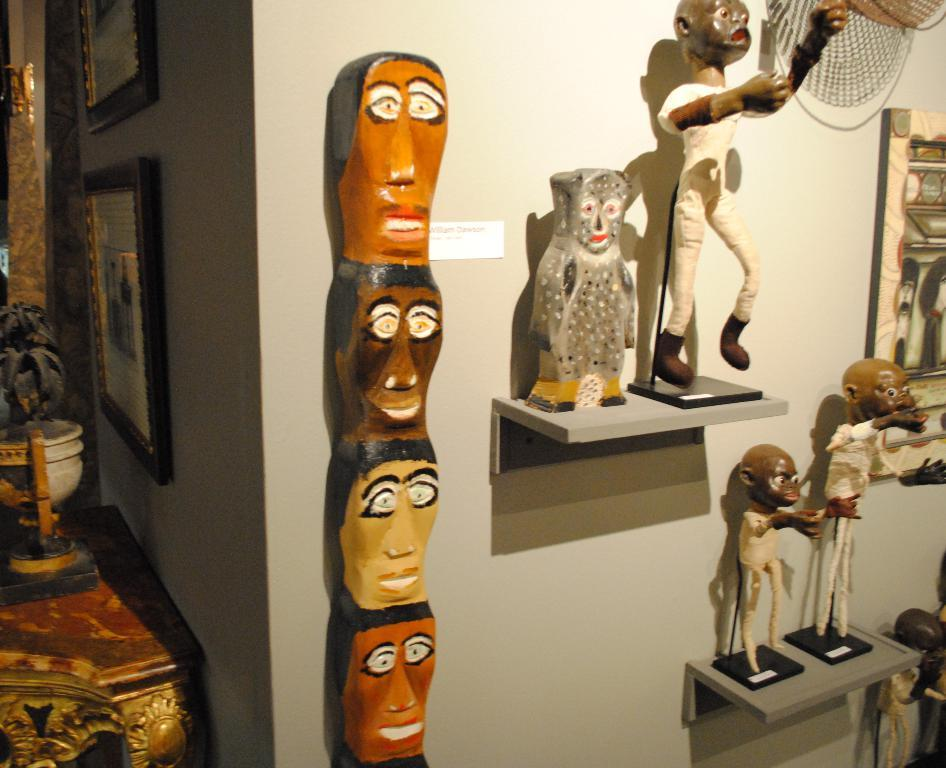What is hanging on the wall in the image? There are photo frames on the wall. What can be seen on the shelves in the image? There are shelves with statues in the image. What is on the table in the image? There is a table with a potted plant in the image. What type of pest can be seen crawling on the photo frames in the image? There is no pest visible in the image; it only features photo frames, shelves with statues, and a table with a potted plant. Who is the writer of the book on the table in the image? There is no book visible in the image; it only features photo frames, shelves with statues, and a table with a potted plant. 